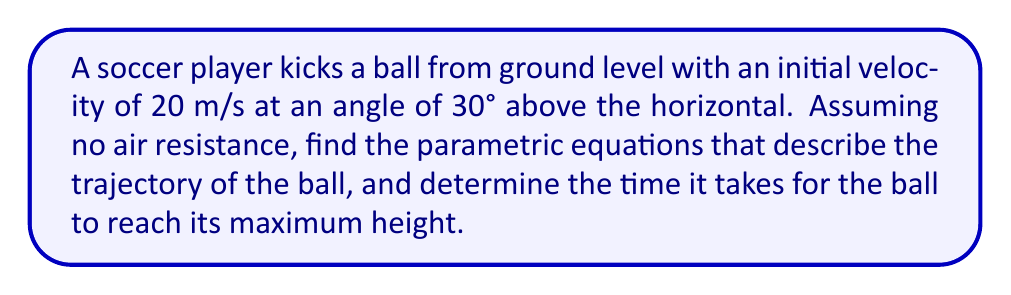Help me with this question. Let's approach this step-by-step:

1) First, we need to define our parametric equations. In general, for projectile motion:

   $$x(t) = v_0 \cos(\theta) t$$
   $$y(t) = v_0 \sin(\theta) t - \frac{1}{2}gt^2$$

   Where $v_0$ is the initial velocity, $\theta$ is the angle, $t$ is time, and $g$ is the acceleration due to gravity (9.8 m/s²).

2) Given:
   - Initial velocity $v_0 = 20$ m/s
   - Angle $\theta = 30°$
   - $g = 9.8$ m/s²

3) Let's substitute these values:

   $$x(t) = 20 \cos(30°) t = 20 \cdot \frac{\sqrt{3}}{2} t = 10\sqrt{3} t$$
   $$y(t) = 20 \sin(30°) t - \frac{1}{2}(9.8)t^2 = 20 \cdot \frac{1}{2} t - 4.9t^2 = 10t - 4.9t^2$$

4) To find the time to reach maximum height, we need to find when the vertical velocity is zero:

   $$\frac{dy}{dt} = 10 - 9.8t = 0$$
   $$9.8t = 10$$
   $$t = \frac{10}{9.8} \approx 1.02 \text{ seconds}$$
Answer: $x(t) = 10\sqrt{3}t$, $y(t) = 10t - 4.9t^2$, Time to max height: 1.02 s 